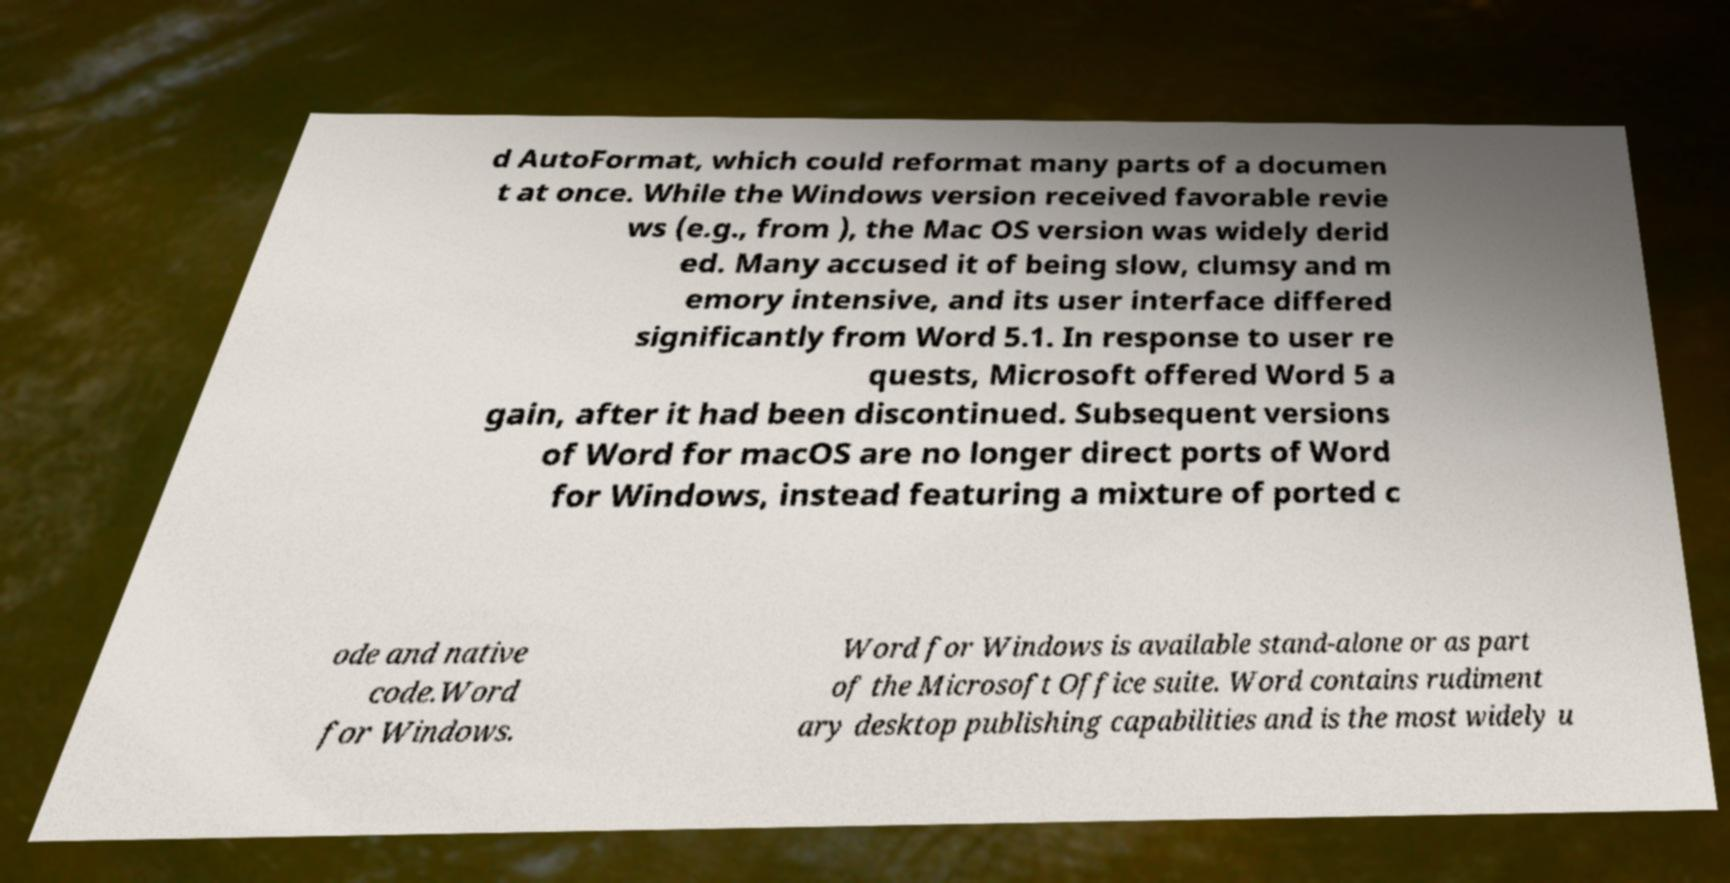There's text embedded in this image that I need extracted. Can you transcribe it verbatim? d AutoFormat, which could reformat many parts of a documen t at once. While the Windows version received favorable revie ws (e.g., from ), the Mac OS version was widely derid ed. Many accused it of being slow, clumsy and m emory intensive, and its user interface differed significantly from Word 5.1. In response to user re quests, Microsoft offered Word 5 a gain, after it had been discontinued. Subsequent versions of Word for macOS are no longer direct ports of Word for Windows, instead featuring a mixture of ported c ode and native code.Word for Windows. Word for Windows is available stand-alone or as part of the Microsoft Office suite. Word contains rudiment ary desktop publishing capabilities and is the most widely u 